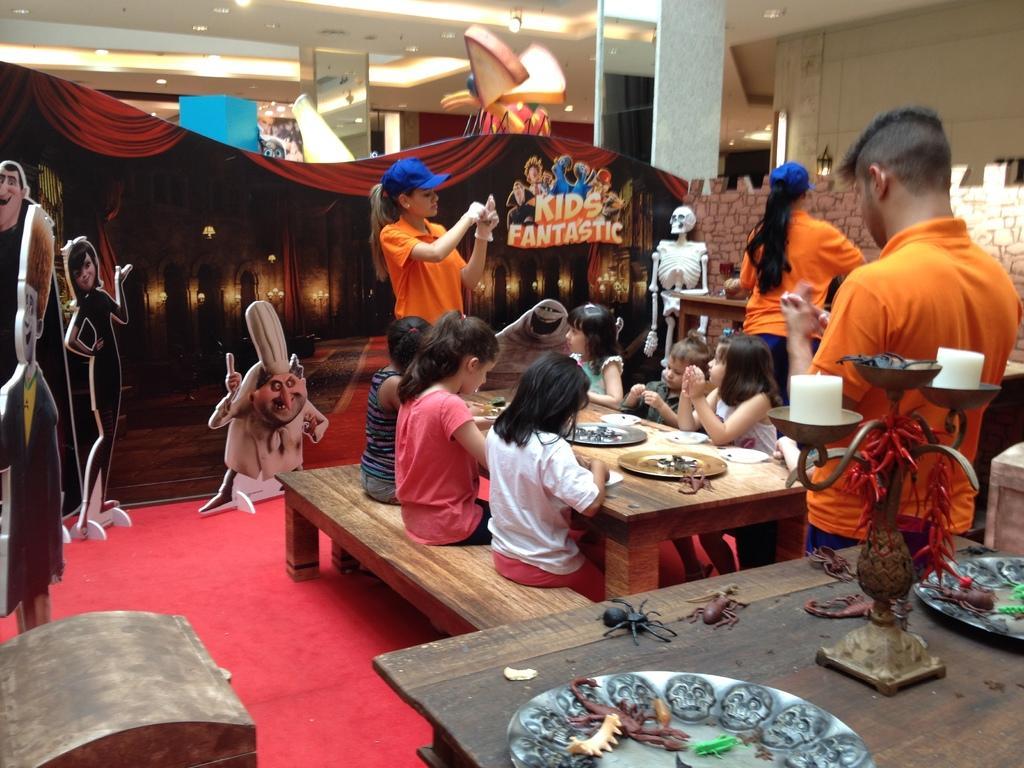How would you summarize this image in a sentence or two? In this image I can see children sitting on the benches. There are food items and plates on the table. In the bottom right corner there is another table with toys and some other objects on it. There are three people standing , there are boards and there is a skeleton. Also there are walls, pillars and there is ceiling with lights. 